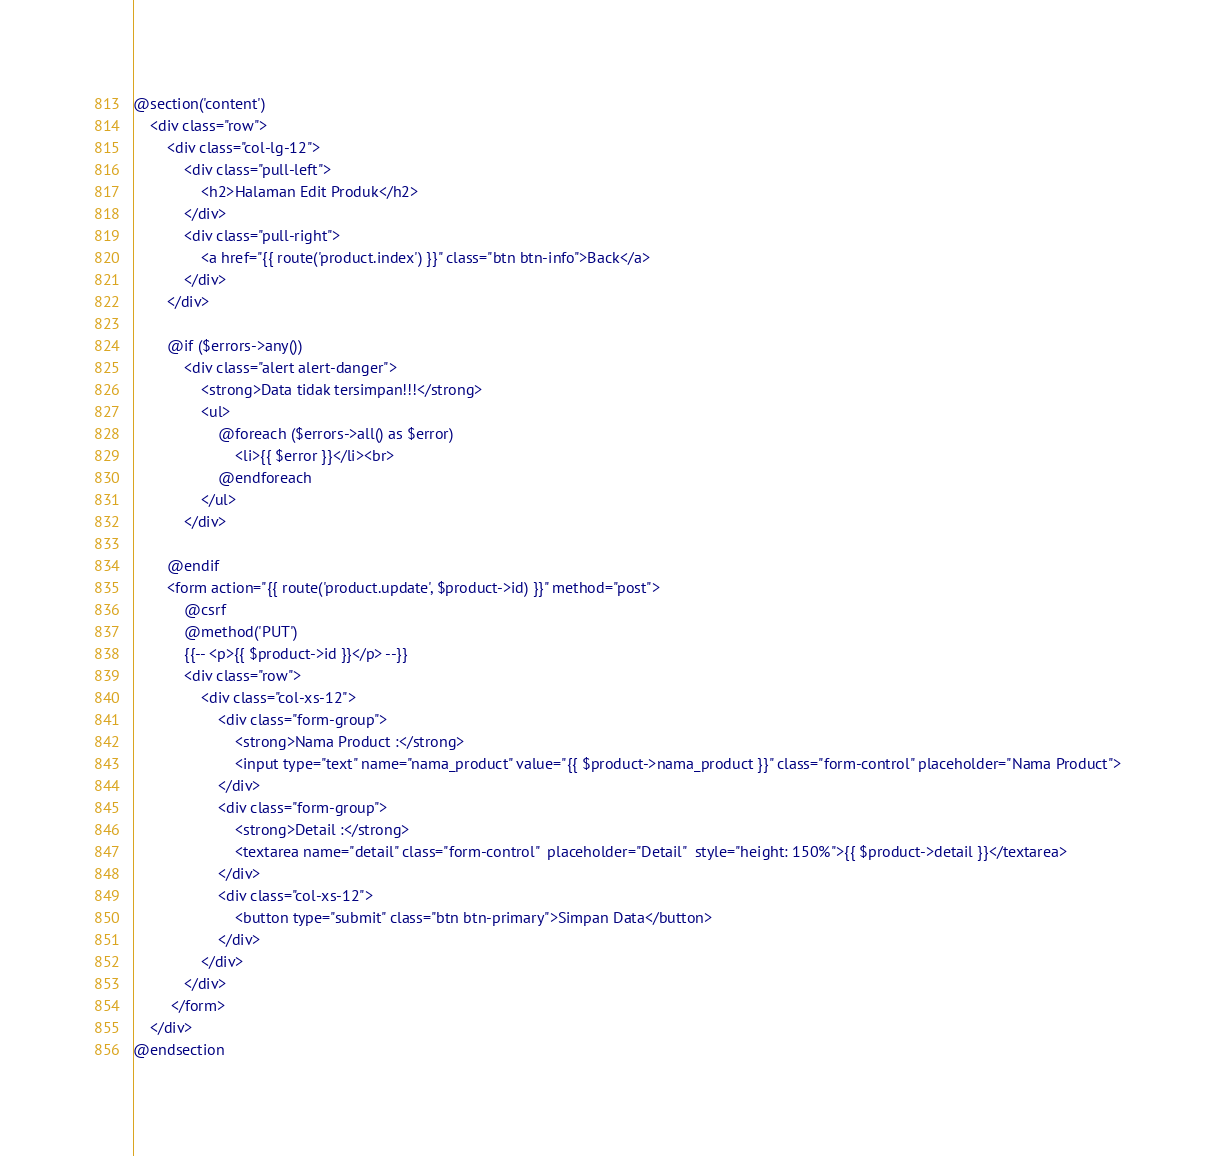<code> <loc_0><loc_0><loc_500><loc_500><_PHP_>
@section('content')
    <div class="row">
        <div class="col-lg-12">
            <div class="pull-left">
                <h2>Halaman Edit Produk</h2>
            </div>
            <div class="pull-right">
                <a href="{{ route('product.index') }}" class="btn btn-info">Back</a>
            </div>
        </div>

        @if ($errors->any())
            <div class="alert alert-danger">
                <strong>Data tidak tersimpan!!!</strong>
                <ul>
                    @foreach ($errors->all() as $error)
                        <li>{{ $error }}</li><br>
                    @endforeach
                </ul>
            </div>
            
        @endif
        <form action="{{ route('product.update', $product->id) }}" method="post">
            @csrf
            @method('PUT')
            {{-- <p>{{ $product->id }}</p> --}}
            <div class="row">
                <div class="col-xs-12">
                    <div class="form-group">
                        <strong>Nama Product :</strong>
                        <input type="text" name="nama_product" value="{{ $product->nama_product }}" class="form-control" placeholder="Nama Product">
                    </div>
                    <div class="form-group">
                        <strong>Detail :</strong>
                        <textarea name="detail" class="form-control"  placeholder="Detail"  style="height: 150%">{{ $product->detail }}</textarea>
                    </div>
                    <div class="col-xs-12">
                        <button type="submit" class="btn btn-primary">Simpan Data</button>
                    </div>
                </div>
            </div>
         </form>
    </div>
@endsection</code> 